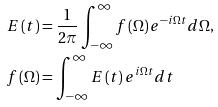Convert formula to latex. <formula><loc_0><loc_0><loc_500><loc_500>E \left ( t \right ) & = \frac { 1 } { 2 \pi } \int _ { - \infty } ^ { \infty } f \left ( \Omega \right ) e ^ { - i \Omega t } d \Omega \text {,} \\ f \left ( \Omega \right ) & = \int _ { - \infty } ^ { \infty } E \left ( t \right ) e ^ { i \Omega t } d t</formula> 